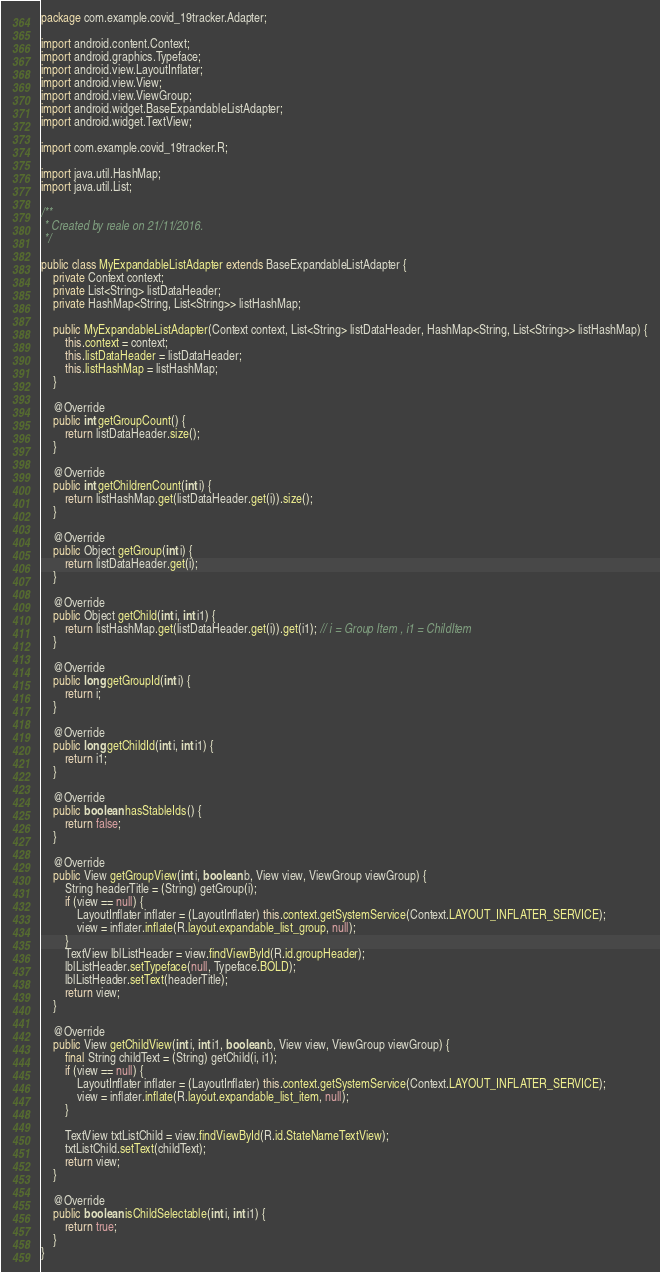Convert code to text. <code><loc_0><loc_0><loc_500><loc_500><_Java_>package com.example.covid_19tracker.Adapter;

import android.content.Context;
import android.graphics.Typeface;
import android.view.LayoutInflater;
import android.view.View;
import android.view.ViewGroup;
import android.widget.BaseExpandableListAdapter;
import android.widget.TextView;

import com.example.covid_19tracker.R;

import java.util.HashMap;
import java.util.List;

/**
 * Created by reale on 21/11/2016.
 */

public class MyExpandableListAdapter extends BaseExpandableListAdapter {
    private Context context;
    private List<String> listDataHeader;
    private HashMap<String, List<String>> listHashMap;

    public MyExpandableListAdapter(Context context, List<String> listDataHeader, HashMap<String, List<String>> listHashMap) {
        this.context = context;
        this.listDataHeader = listDataHeader;
        this.listHashMap = listHashMap;
    }

    @Override
    public int getGroupCount() {
        return listDataHeader.size();
    }

    @Override
    public int getChildrenCount(int i) {
        return listHashMap.get(listDataHeader.get(i)).size();
    }

    @Override
    public Object getGroup(int i) {
        return listDataHeader.get(i);
    }

    @Override
    public Object getChild(int i, int i1) {
        return listHashMap.get(listDataHeader.get(i)).get(i1); // i = Group Item , i1 = ChildItem
    }

    @Override
    public long getGroupId(int i) {
        return i;
    }

    @Override
    public long getChildId(int i, int i1) {
        return i1;
    }

    @Override
    public boolean hasStableIds() {
        return false;
    }

    @Override
    public View getGroupView(int i, boolean b, View view, ViewGroup viewGroup) {
        String headerTitle = (String) getGroup(i);
        if (view == null) {
            LayoutInflater inflater = (LayoutInflater) this.context.getSystemService(Context.LAYOUT_INFLATER_SERVICE);
            view = inflater.inflate(R.layout.expandable_list_group, null);
        }
        TextView lblListHeader = view.findViewById(R.id.groupHeader);
        lblListHeader.setTypeface(null, Typeface.BOLD);
        lblListHeader.setText(headerTitle);
        return view;
    }

    @Override
    public View getChildView(int i, int i1, boolean b, View view, ViewGroup viewGroup) {
        final String childText = (String) getChild(i, i1);
        if (view == null) {
            LayoutInflater inflater = (LayoutInflater) this.context.getSystemService(Context.LAYOUT_INFLATER_SERVICE);
            view = inflater.inflate(R.layout.expandable_list_item, null);
        }

        TextView txtListChild = view.findViewById(R.id.StateNameTextView);
        txtListChild.setText(childText);
        return view;
    }

    @Override
    public boolean isChildSelectable(int i, int i1) {
        return true;
    }
}</code> 